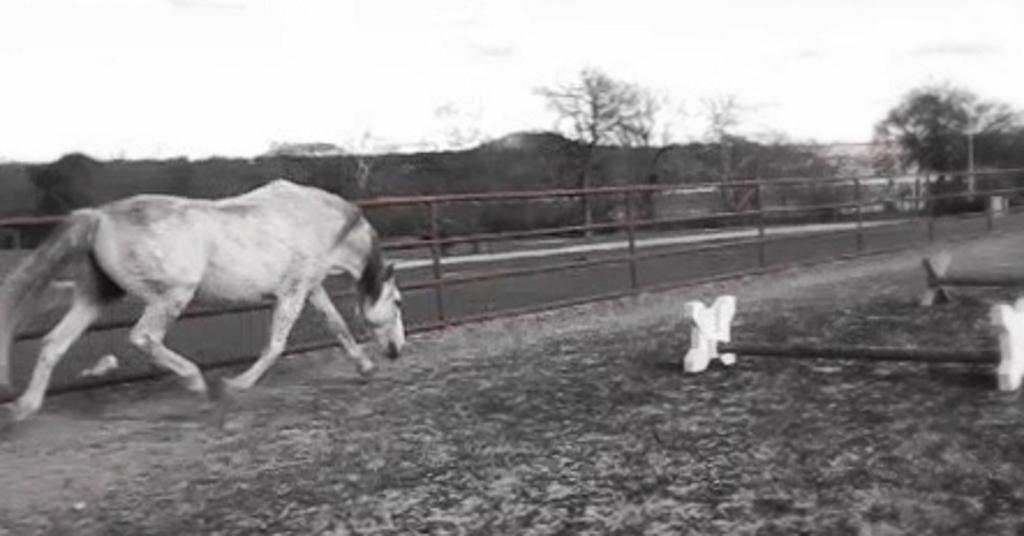What is the color scheme of the image? The image is black and white. What animal can be seen on the left side of the image? There is a horse on the left side of the image. What is the horse doing in the image? The horse is running on the ground. What structures are present in the image? There is a fence and rods in the image. What can be seen in the background of the image? There are trees and the sky visible in the background of the image. What time of day is it in the image, based on the hour? The image is black and white, so it is not possible to determine the time of day or hour of day from the image. 